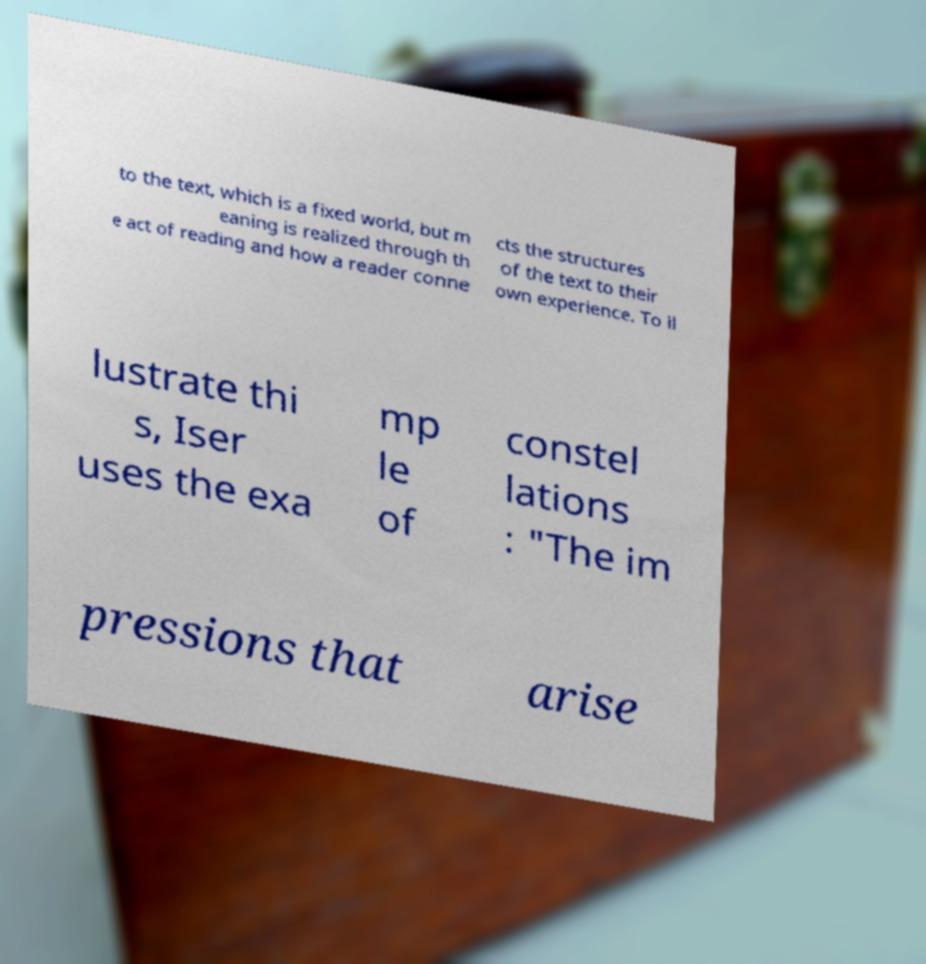Can you read and provide the text displayed in the image?This photo seems to have some interesting text. Can you extract and type it out for me? to the text, which is a fixed world, but m eaning is realized through th e act of reading and how a reader conne cts the structures of the text to their own experience. To il lustrate thi s, Iser uses the exa mp le of constel lations : "The im pressions that arise 